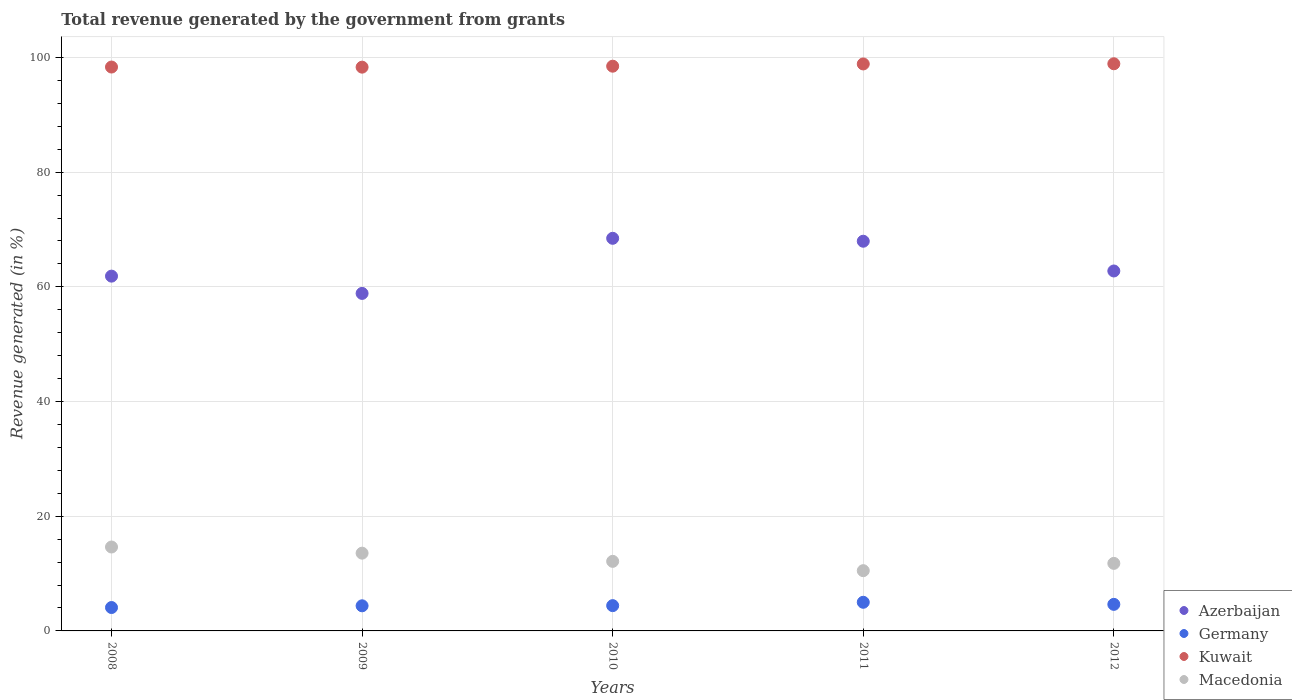How many different coloured dotlines are there?
Provide a succinct answer. 4. Is the number of dotlines equal to the number of legend labels?
Offer a very short reply. Yes. What is the total revenue generated in Macedonia in 2008?
Your response must be concise. 14.63. Across all years, what is the maximum total revenue generated in Macedonia?
Your answer should be very brief. 14.63. Across all years, what is the minimum total revenue generated in Kuwait?
Keep it short and to the point. 98.31. In which year was the total revenue generated in Macedonia maximum?
Provide a succinct answer. 2008. What is the total total revenue generated in Azerbaijan in the graph?
Offer a terse response. 319.89. What is the difference between the total revenue generated in Macedonia in 2009 and that in 2010?
Your answer should be very brief. 1.43. What is the difference between the total revenue generated in Azerbaijan in 2012 and the total revenue generated in Macedonia in 2009?
Provide a short and direct response. 49.2. What is the average total revenue generated in Azerbaijan per year?
Your response must be concise. 63.98. In the year 2012, what is the difference between the total revenue generated in Kuwait and total revenue generated in Germany?
Your answer should be very brief. 94.27. In how many years, is the total revenue generated in Kuwait greater than 64 %?
Make the answer very short. 5. What is the ratio of the total revenue generated in Kuwait in 2008 to that in 2010?
Offer a terse response. 1. Is the total revenue generated in Macedonia in 2010 less than that in 2012?
Provide a short and direct response. No. Is the difference between the total revenue generated in Kuwait in 2009 and 2011 greater than the difference between the total revenue generated in Germany in 2009 and 2011?
Your answer should be compact. Yes. What is the difference between the highest and the second highest total revenue generated in Azerbaijan?
Your answer should be very brief. 0.51. What is the difference between the highest and the lowest total revenue generated in Kuwait?
Provide a succinct answer. 0.59. In how many years, is the total revenue generated in Macedonia greater than the average total revenue generated in Macedonia taken over all years?
Offer a very short reply. 2. Is it the case that in every year, the sum of the total revenue generated in Azerbaijan and total revenue generated in Kuwait  is greater than the total revenue generated in Germany?
Your answer should be very brief. Yes. Is the total revenue generated in Macedonia strictly less than the total revenue generated in Azerbaijan over the years?
Your answer should be very brief. Yes. How many dotlines are there?
Give a very brief answer. 4. How many years are there in the graph?
Keep it short and to the point. 5. What is the difference between two consecutive major ticks on the Y-axis?
Make the answer very short. 20. Does the graph contain any zero values?
Ensure brevity in your answer.  No. Where does the legend appear in the graph?
Your answer should be compact. Bottom right. How many legend labels are there?
Provide a short and direct response. 4. What is the title of the graph?
Your answer should be compact. Total revenue generated by the government from grants. Does "Greenland" appear as one of the legend labels in the graph?
Offer a very short reply. No. What is the label or title of the Y-axis?
Offer a terse response. Revenue generated (in %). What is the Revenue generated (in %) in Azerbaijan in 2008?
Give a very brief answer. 61.87. What is the Revenue generated (in %) of Germany in 2008?
Give a very brief answer. 4.08. What is the Revenue generated (in %) in Kuwait in 2008?
Ensure brevity in your answer.  98.33. What is the Revenue generated (in %) in Macedonia in 2008?
Make the answer very short. 14.63. What is the Revenue generated (in %) of Azerbaijan in 2009?
Provide a succinct answer. 58.85. What is the Revenue generated (in %) of Germany in 2009?
Give a very brief answer. 4.38. What is the Revenue generated (in %) in Kuwait in 2009?
Keep it short and to the point. 98.31. What is the Revenue generated (in %) in Macedonia in 2009?
Ensure brevity in your answer.  13.56. What is the Revenue generated (in %) of Azerbaijan in 2010?
Ensure brevity in your answer.  68.46. What is the Revenue generated (in %) of Germany in 2010?
Offer a terse response. 4.41. What is the Revenue generated (in %) in Kuwait in 2010?
Your answer should be very brief. 98.47. What is the Revenue generated (in %) of Macedonia in 2010?
Your response must be concise. 12.13. What is the Revenue generated (in %) of Azerbaijan in 2011?
Your response must be concise. 67.95. What is the Revenue generated (in %) of Germany in 2011?
Your response must be concise. 4.99. What is the Revenue generated (in %) of Kuwait in 2011?
Offer a very short reply. 98.86. What is the Revenue generated (in %) in Macedonia in 2011?
Your answer should be compact. 10.51. What is the Revenue generated (in %) of Azerbaijan in 2012?
Keep it short and to the point. 62.76. What is the Revenue generated (in %) of Germany in 2012?
Keep it short and to the point. 4.63. What is the Revenue generated (in %) in Kuwait in 2012?
Offer a very short reply. 98.9. What is the Revenue generated (in %) of Macedonia in 2012?
Give a very brief answer. 11.78. Across all years, what is the maximum Revenue generated (in %) in Azerbaijan?
Your answer should be very brief. 68.46. Across all years, what is the maximum Revenue generated (in %) of Germany?
Provide a short and direct response. 4.99. Across all years, what is the maximum Revenue generated (in %) of Kuwait?
Ensure brevity in your answer.  98.9. Across all years, what is the maximum Revenue generated (in %) of Macedonia?
Make the answer very short. 14.63. Across all years, what is the minimum Revenue generated (in %) of Azerbaijan?
Provide a succinct answer. 58.85. Across all years, what is the minimum Revenue generated (in %) in Germany?
Keep it short and to the point. 4.08. Across all years, what is the minimum Revenue generated (in %) in Kuwait?
Offer a very short reply. 98.31. Across all years, what is the minimum Revenue generated (in %) of Macedonia?
Offer a terse response. 10.51. What is the total Revenue generated (in %) in Azerbaijan in the graph?
Your answer should be compact. 319.89. What is the total Revenue generated (in %) in Germany in the graph?
Offer a very short reply. 22.49. What is the total Revenue generated (in %) in Kuwait in the graph?
Your response must be concise. 492.87. What is the total Revenue generated (in %) of Macedonia in the graph?
Provide a succinct answer. 62.61. What is the difference between the Revenue generated (in %) of Azerbaijan in 2008 and that in 2009?
Offer a very short reply. 3.01. What is the difference between the Revenue generated (in %) in Germany in 2008 and that in 2009?
Offer a very short reply. -0.3. What is the difference between the Revenue generated (in %) of Kuwait in 2008 and that in 2009?
Your response must be concise. 0.02. What is the difference between the Revenue generated (in %) in Macedonia in 2008 and that in 2009?
Make the answer very short. 1.07. What is the difference between the Revenue generated (in %) of Azerbaijan in 2008 and that in 2010?
Your answer should be compact. -6.6. What is the difference between the Revenue generated (in %) of Germany in 2008 and that in 2010?
Your response must be concise. -0.33. What is the difference between the Revenue generated (in %) of Kuwait in 2008 and that in 2010?
Provide a short and direct response. -0.15. What is the difference between the Revenue generated (in %) of Macedonia in 2008 and that in 2010?
Make the answer very short. 2.5. What is the difference between the Revenue generated (in %) of Azerbaijan in 2008 and that in 2011?
Ensure brevity in your answer.  -6.09. What is the difference between the Revenue generated (in %) of Germany in 2008 and that in 2011?
Offer a very short reply. -0.91. What is the difference between the Revenue generated (in %) in Kuwait in 2008 and that in 2011?
Ensure brevity in your answer.  -0.54. What is the difference between the Revenue generated (in %) of Macedonia in 2008 and that in 2011?
Provide a succinct answer. 4.12. What is the difference between the Revenue generated (in %) of Azerbaijan in 2008 and that in 2012?
Keep it short and to the point. -0.9. What is the difference between the Revenue generated (in %) in Germany in 2008 and that in 2012?
Offer a very short reply. -0.55. What is the difference between the Revenue generated (in %) in Kuwait in 2008 and that in 2012?
Your answer should be compact. -0.57. What is the difference between the Revenue generated (in %) in Macedonia in 2008 and that in 2012?
Offer a very short reply. 2.85. What is the difference between the Revenue generated (in %) of Azerbaijan in 2009 and that in 2010?
Provide a succinct answer. -9.61. What is the difference between the Revenue generated (in %) of Germany in 2009 and that in 2010?
Your answer should be very brief. -0.03. What is the difference between the Revenue generated (in %) in Kuwait in 2009 and that in 2010?
Provide a short and direct response. -0.17. What is the difference between the Revenue generated (in %) in Macedonia in 2009 and that in 2010?
Your answer should be compact. 1.43. What is the difference between the Revenue generated (in %) in Azerbaijan in 2009 and that in 2011?
Make the answer very short. -9.1. What is the difference between the Revenue generated (in %) in Germany in 2009 and that in 2011?
Give a very brief answer. -0.61. What is the difference between the Revenue generated (in %) in Kuwait in 2009 and that in 2011?
Keep it short and to the point. -0.56. What is the difference between the Revenue generated (in %) in Macedonia in 2009 and that in 2011?
Your answer should be very brief. 3.05. What is the difference between the Revenue generated (in %) of Azerbaijan in 2009 and that in 2012?
Ensure brevity in your answer.  -3.91. What is the difference between the Revenue generated (in %) in Germany in 2009 and that in 2012?
Offer a very short reply. -0.25. What is the difference between the Revenue generated (in %) in Kuwait in 2009 and that in 2012?
Offer a terse response. -0.59. What is the difference between the Revenue generated (in %) of Macedonia in 2009 and that in 2012?
Your answer should be very brief. 1.78. What is the difference between the Revenue generated (in %) of Azerbaijan in 2010 and that in 2011?
Offer a terse response. 0.51. What is the difference between the Revenue generated (in %) of Germany in 2010 and that in 2011?
Give a very brief answer. -0.59. What is the difference between the Revenue generated (in %) of Kuwait in 2010 and that in 2011?
Offer a very short reply. -0.39. What is the difference between the Revenue generated (in %) of Macedonia in 2010 and that in 2011?
Offer a terse response. 1.63. What is the difference between the Revenue generated (in %) of Azerbaijan in 2010 and that in 2012?
Give a very brief answer. 5.7. What is the difference between the Revenue generated (in %) in Germany in 2010 and that in 2012?
Keep it short and to the point. -0.22. What is the difference between the Revenue generated (in %) of Kuwait in 2010 and that in 2012?
Ensure brevity in your answer.  -0.42. What is the difference between the Revenue generated (in %) of Macedonia in 2010 and that in 2012?
Provide a short and direct response. 0.35. What is the difference between the Revenue generated (in %) in Azerbaijan in 2011 and that in 2012?
Your answer should be very brief. 5.19. What is the difference between the Revenue generated (in %) of Germany in 2011 and that in 2012?
Ensure brevity in your answer.  0.36. What is the difference between the Revenue generated (in %) in Kuwait in 2011 and that in 2012?
Your answer should be very brief. -0.03. What is the difference between the Revenue generated (in %) in Macedonia in 2011 and that in 2012?
Keep it short and to the point. -1.27. What is the difference between the Revenue generated (in %) in Azerbaijan in 2008 and the Revenue generated (in %) in Germany in 2009?
Your response must be concise. 57.49. What is the difference between the Revenue generated (in %) in Azerbaijan in 2008 and the Revenue generated (in %) in Kuwait in 2009?
Offer a very short reply. -36.44. What is the difference between the Revenue generated (in %) of Azerbaijan in 2008 and the Revenue generated (in %) of Macedonia in 2009?
Give a very brief answer. 48.3. What is the difference between the Revenue generated (in %) of Germany in 2008 and the Revenue generated (in %) of Kuwait in 2009?
Your response must be concise. -94.23. What is the difference between the Revenue generated (in %) in Germany in 2008 and the Revenue generated (in %) in Macedonia in 2009?
Ensure brevity in your answer.  -9.48. What is the difference between the Revenue generated (in %) in Kuwait in 2008 and the Revenue generated (in %) in Macedonia in 2009?
Provide a short and direct response. 84.77. What is the difference between the Revenue generated (in %) in Azerbaijan in 2008 and the Revenue generated (in %) in Germany in 2010?
Give a very brief answer. 57.46. What is the difference between the Revenue generated (in %) of Azerbaijan in 2008 and the Revenue generated (in %) of Kuwait in 2010?
Offer a very short reply. -36.61. What is the difference between the Revenue generated (in %) of Azerbaijan in 2008 and the Revenue generated (in %) of Macedonia in 2010?
Ensure brevity in your answer.  49.73. What is the difference between the Revenue generated (in %) of Germany in 2008 and the Revenue generated (in %) of Kuwait in 2010?
Provide a short and direct response. -94.4. What is the difference between the Revenue generated (in %) of Germany in 2008 and the Revenue generated (in %) of Macedonia in 2010?
Offer a terse response. -8.05. What is the difference between the Revenue generated (in %) of Kuwait in 2008 and the Revenue generated (in %) of Macedonia in 2010?
Provide a succinct answer. 86.19. What is the difference between the Revenue generated (in %) of Azerbaijan in 2008 and the Revenue generated (in %) of Germany in 2011?
Ensure brevity in your answer.  56.87. What is the difference between the Revenue generated (in %) in Azerbaijan in 2008 and the Revenue generated (in %) in Kuwait in 2011?
Provide a short and direct response. -37. What is the difference between the Revenue generated (in %) of Azerbaijan in 2008 and the Revenue generated (in %) of Macedonia in 2011?
Keep it short and to the point. 51.36. What is the difference between the Revenue generated (in %) in Germany in 2008 and the Revenue generated (in %) in Kuwait in 2011?
Keep it short and to the point. -94.79. What is the difference between the Revenue generated (in %) in Germany in 2008 and the Revenue generated (in %) in Macedonia in 2011?
Your answer should be very brief. -6.43. What is the difference between the Revenue generated (in %) of Kuwait in 2008 and the Revenue generated (in %) of Macedonia in 2011?
Ensure brevity in your answer.  87.82. What is the difference between the Revenue generated (in %) in Azerbaijan in 2008 and the Revenue generated (in %) in Germany in 2012?
Your answer should be very brief. 57.23. What is the difference between the Revenue generated (in %) of Azerbaijan in 2008 and the Revenue generated (in %) of Kuwait in 2012?
Your response must be concise. -37.03. What is the difference between the Revenue generated (in %) in Azerbaijan in 2008 and the Revenue generated (in %) in Macedonia in 2012?
Your answer should be very brief. 50.09. What is the difference between the Revenue generated (in %) of Germany in 2008 and the Revenue generated (in %) of Kuwait in 2012?
Give a very brief answer. -94.82. What is the difference between the Revenue generated (in %) of Germany in 2008 and the Revenue generated (in %) of Macedonia in 2012?
Your answer should be very brief. -7.7. What is the difference between the Revenue generated (in %) of Kuwait in 2008 and the Revenue generated (in %) of Macedonia in 2012?
Provide a succinct answer. 86.55. What is the difference between the Revenue generated (in %) in Azerbaijan in 2009 and the Revenue generated (in %) in Germany in 2010?
Your response must be concise. 54.44. What is the difference between the Revenue generated (in %) of Azerbaijan in 2009 and the Revenue generated (in %) of Kuwait in 2010?
Your response must be concise. -39.62. What is the difference between the Revenue generated (in %) in Azerbaijan in 2009 and the Revenue generated (in %) in Macedonia in 2010?
Offer a very short reply. 46.72. What is the difference between the Revenue generated (in %) of Germany in 2009 and the Revenue generated (in %) of Kuwait in 2010?
Keep it short and to the point. -94.1. What is the difference between the Revenue generated (in %) in Germany in 2009 and the Revenue generated (in %) in Macedonia in 2010?
Your answer should be very brief. -7.75. What is the difference between the Revenue generated (in %) of Kuwait in 2009 and the Revenue generated (in %) of Macedonia in 2010?
Provide a succinct answer. 86.17. What is the difference between the Revenue generated (in %) of Azerbaijan in 2009 and the Revenue generated (in %) of Germany in 2011?
Provide a short and direct response. 53.86. What is the difference between the Revenue generated (in %) of Azerbaijan in 2009 and the Revenue generated (in %) of Kuwait in 2011?
Your answer should be very brief. -40.01. What is the difference between the Revenue generated (in %) in Azerbaijan in 2009 and the Revenue generated (in %) in Macedonia in 2011?
Your answer should be compact. 48.35. What is the difference between the Revenue generated (in %) in Germany in 2009 and the Revenue generated (in %) in Kuwait in 2011?
Give a very brief answer. -94.49. What is the difference between the Revenue generated (in %) of Germany in 2009 and the Revenue generated (in %) of Macedonia in 2011?
Provide a short and direct response. -6.13. What is the difference between the Revenue generated (in %) in Kuwait in 2009 and the Revenue generated (in %) in Macedonia in 2011?
Give a very brief answer. 87.8. What is the difference between the Revenue generated (in %) in Azerbaijan in 2009 and the Revenue generated (in %) in Germany in 2012?
Your answer should be compact. 54.22. What is the difference between the Revenue generated (in %) in Azerbaijan in 2009 and the Revenue generated (in %) in Kuwait in 2012?
Provide a succinct answer. -40.05. What is the difference between the Revenue generated (in %) in Azerbaijan in 2009 and the Revenue generated (in %) in Macedonia in 2012?
Provide a succinct answer. 47.07. What is the difference between the Revenue generated (in %) of Germany in 2009 and the Revenue generated (in %) of Kuwait in 2012?
Give a very brief answer. -94.52. What is the difference between the Revenue generated (in %) of Germany in 2009 and the Revenue generated (in %) of Macedonia in 2012?
Provide a succinct answer. -7.4. What is the difference between the Revenue generated (in %) in Kuwait in 2009 and the Revenue generated (in %) in Macedonia in 2012?
Offer a very short reply. 86.53. What is the difference between the Revenue generated (in %) in Azerbaijan in 2010 and the Revenue generated (in %) in Germany in 2011?
Ensure brevity in your answer.  63.47. What is the difference between the Revenue generated (in %) of Azerbaijan in 2010 and the Revenue generated (in %) of Kuwait in 2011?
Provide a succinct answer. -30.4. What is the difference between the Revenue generated (in %) in Azerbaijan in 2010 and the Revenue generated (in %) in Macedonia in 2011?
Provide a short and direct response. 57.96. What is the difference between the Revenue generated (in %) in Germany in 2010 and the Revenue generated (in %) in Kuwait in 2011?
Provide a short and direct response. -94.46. What is the difference between the Revenue generated (in %) in Germany in 2010 and the Revenue generated (in %) in Macedonia in 2011?
Give a very brief answer. -6.1. What is the difference between the Revenue generated (in %) in Kuwait in 2010 and the Revenue generated (in %) in Macedonia in 2011?
Provide a succinct answer. 87.97. What is the difference between the Revenue generated (in %) in Azerbaijan in 2010 and the Revenue generated (in %) in Germany in 2012?
Offer a very short reply. 63.83. What is the difference between the Revenue generated (in %) in Azerbaijan in 2010 and the Revenue generated (in %) in Kuwait in 2012?
Ensure brevity in your answer.  -30.44. What is the difference between the Revenue generated (in %) of Azerbaijan in 2010 and the Revenue generated (in %) of Macedonia in 2012?
Provide a succinct answer. 56.68. What is the difference between the Revenue generated (in %) of Germany in 2010 and the Revenue generated (in %) of Kuwait in 2012?
Keep it short and to the point. -94.49. What is the difference between the Revenue generated (in %) of Germany in 2010 and the Revenue generated (in %) of Macedonia in 2012?
Provide a succinct answer. -7.37. What is the difference between the Revenue generated (in %) in Kuwait in 2010 and the Revenue generated (in %) in Macedonia in 2012?
Offer a terse response. 86.7. What is the difference between the Revenue generated (in %) in Azerbaijan in 2011 and the Revenue generated (in %) in Germany in 2012?
Provide a short and direct response. 63.32. What is the difference between the Revenue generated (in %) of Azerbaijan in 2011 and the Revenue generated (in %) of Kuwait in 2012?
Give a very brief answer. -30.95. What is the difference between the Revenue generated (in %) in Azerbaijan in 2011 and the Revenue generated (in %) in Macedonia in 2012?
Provide a succinct answer. 56.17. What is the difference between the Revenue generated (in %) of Germany in 2011 and the Revenue generated (in %) of Kuwait in 2012?
Offer a very short reply. -93.9. What is the difference between the Revenue generated (in %) in Germany in 2011 and the Revenue generated (in %) in Macedonia in 2012?
Offer a very short reply. -6.78. What is the difference between the Revenue generated (in %) of Kuwait in 2011 and the Revenue generated (in %) of Macedonia in 2012?
Ensure brevity in your answer.  87.09. What is the average Revenue generated (in %) in Azerbaijan per year?
Your answer should be very brief. 63.98. What is the average Revenue generated (in %) in Germany per year?
Your answer should be very brief. 4.5. What is the average Revenue generated (in %) of Kuwait per year?
Offer a very short reply. 98.57. What is the average Revenue generated (in %) in Macedonia per year?
Offer a very short reply. 12.52. In the year 2008, what is the difference between the Revenue generated (in %) in Azerbaijan and Revenue generated (in %) in Germany?
Ensure brevity in your answer.  57.79. In the year 2008, what is the difference between the Revenue generated (in %) in Azerbaijan and Revenue generated (in %) in Kuwait?
Offer a very short reply. -36.46. In the year 2008, what is the difference between the Revenue generated (in %) of Azerbaijan and Revenue generated (in %) of Macedonia?
Make the answer very short. 47.23. In the year 2008, what is the difference between the Revenue generated (in %) of Germany and Revenue generated (in %) of Kuwait?
Give a very brief answer. -94.25. In the year 2008, what is the difference between the Revenue generated (in %) of Germany and Revenue generated (in %) of Macedonia?
Give a very brief answer. -10.55. In the year 2008, what is the difference between the Revenue generated (in %) of Kuwait and Revenue generated (in %) of Macedonia?
Provide a short and direct response. 83.69. In the year 2009, what is the difference between the Revenue generated (in %) of Azerbaijan and Revenue generated (in %) of Germany?
Provide a short and direct response. 54.47. In the year 2009, what is the difference between the Revenue generated (in %) of Azerbaijan and Revenue generated (in %) of Kuwait?
Provide a succinct answer. -39.45. In the year 2009, what is the difference between the Revenue generated (in %) of Azerbaijan and Revenue generated (in %) of Macedonia?
Make the answer very short. 45.29. In the year 2009, what is the difference between the Revenue generated (in %) of Germany and Revenue generated (in %) of Kuwait?
Give a very brief answer. -93.93. In the year 2009, what is the difference between the Revenue generated (in %) in Germany and Revenue generated (in %) in Macedonia?
Your answer should be very brief. -9.18. In the year 2009, what is the difference between the Revenue generated (in %) in Kuwait and Revenue generated (in %) in Macedonia?
Your answer should be compact. 84.75. In the year 2010, what is the difference between the Revenue generated (in %) of Azerbaijan and Revenue generated (in %) of Germany?
Provide a succinct answer. 64.05. In the year 2010, what is the difference between the Revenue generated (in %) of Azerbaijan and Revenue generated (in %) of Kuwait?
Give a very brief answer. -30.01. In the year 2010, what is the difference between the Revenue generated (in %) in Azerbaijan and Revenue generated (in %) in Macedonia?
Offer a terse response. 56.33. In the year 2010, what is the difference between the Revenue generated (in %) of Germany and Revenue generated (in %) of Kuwait?
Make the answer very short. -94.07. In the year 2010, what is the difference between the Revenue generated (in %) of Germany and Revenue generated (in %) of Macedonia?
Your answer should be very brief. -7.72. In the year 2010, what is the difference between the Revenue generated (in %) in Kuwait and Revenue generated (in %) in Macedonia?
Ensure brevity in your answer.  86.34. In the year 2011, what is the difference between the Revenue generated (in %) of Azerbaijan and Revenue generated (in %) of Germany?
Your answer should be very brief. 62.96. In the year 2011, what is the difference between the Revenue generated (in %) in Azerbaijan and Revenue generated (in %) in Kuwait?
Your answer should be very brief. -30.91. In the year 2011, what is the difference between the Revenue generated (in %) in Azerbaijan and Revenue generated (in %) in Macedonia?
Provide a succinct answer. 57.45. In the year 2011, what is the difference between the Revenue generated (in %) in Germany and Revenue generated (in %) in Kuwait?
Make the answer very short. -93.87. In the year 2011, what is the difference between the Revenue generated (in %) of Germany and Revenue generated (in %) of Macedonia?
Offer a very short reply. -5.51. In the year 2011, what is the difference between the Revenue generated (in %) of Kuwait and Revenue generated (in %) of Macedonia?
Provide a short and direct response. 88.36. In the year 2012, what is the difference between the Revenue generated (in %) in Azerbaijan and Revenue generated (in %) in Germany?
Keep it short and to the point. 58.13. In the year 2012, what is the difference between the Revenue generated (in %) of Azerbaijan and Revenue generated (in %) of Kuwait?
Your response must be concise. -36.13. In the year 2012, what is the difference between the Revenue generated (in %) of Azerbaijan and Revenue generated (in %) of Macedonia?
Keep it short and to the point. 50.99. In the year 2012, what is the difference between the Revenue generated (in %) of Germany and Revenue generated (in %) of Kuwait?
Your response must be concise. -94.27. In the year 2012, what is the difference between the Revenue generated (in %) in Germany and Revenue generated (in %) in Macedonia?
Your answer should be compact. -7.15. In the year 2012, what is the difference between the Revenue generated (in %) in Kuwait and Revenue generated (in %) in Macedonia?
Your answer should be very brief. 87.12. What is the ratio of the Revenue generated (in %) in Azerbaijan in 2008 to that in 2009?
Keep it short and to the point. 1.05. What is the ratio of the Revenue generated (in %) of Germany in 2008 to that in 2009?
Make the answer very short. 0.93. What is the ratio of the Revenue generated (in %) in Kuwait in 2008 to that in 2009?
Your answer should be very brief. 1. What is the ratio of the Revenue generated (in %) in Macedonia in 2008 to that in 2009?
Provide a short and direct response. 1.08. What is the ratio of the Revenue generated (in %) in Azerbaijan in 2008 to that in 2010?
Ensure brevity in your answer.  0.9. What is the ratio of the Revenue generated (in %) in Germany in 2008 to that in 2010?
Your response must be concise. 0.93. What is the ratio of the Revenue generated (in %) in Macedonia in 2008 to that in 2010?
Your answer should be very brief. 1.21. What is the ratio of the Revenue generated (in %) of Azerbaijan in 2008 to that in 2011?
Your answer should be compact. 0.91. What is the ratio of the Revenue generated (in %) of Germany in 2008 to that in 2011?
Make the answer very short. 0.82. What is the ratio of the Revenue generated (in %) of Kuwait in 2008 to that in 2011?
Your response must be concise. 0.99. What is the ratio of the Revenue generated (in %) in Macedonia in 2008 to that in 2011?
Make the answer very short. 1.39. What is the ratio of the Revenue generated (in %) of Azerbaijan in 2008 to that in 2012?
Your answer should be very brief. 0.99. What is the ratio of the Revenue generated (in %) of Germany in 2008 to that in 2012?
Your answer should be compact. 0.88. What is the ratio of the Revenue generated (in %) in Kuwait in 2008 to that in 2012?
Make the answer very short. 0.99. What is the ratio of the Revenue generated (in %) of Macedonia in 2008 to that in 2012?
Provide a succinct answer. 1.24. What is the ratio of the Revenue generated (in %) in Azerbaijan in 2009 to that in 2010?
Your answer should be very brief. 0.86. What is the ratio of the Revenue generated (in %) in Kuwait in 2009 to that in 2010?
Your answer should be very brief. 1. What is the ratio of the Revenue generated (in %) of Macedonia in 2009 to that in 2010?
Ensure brevity in your answer.  1.12. What is the ratio of the Revenue generated (in %) in Azerbaijan in 2009 to that in 2011?
Make the answer very short. 0.87. What is the ratio of the Revenue generated (in %) of Germany in 2009 to that in 2011?
Keep it short and to the point. 0.88. What is the ratio of the Revenue generated (in %) in Kuwait in 2009 to that in 2011?
Your answer should be compact. 0.99. What is the ratio of the Revenue generated (in %) in Macedonia in 2009 to that in 2011?
Offer a very short reply. 1.29. What is the ratio of the Revenue generated (in %) in Azerbaijan in 2009 to that in 2012?
Offer a very short reply. 0.94. What is the ratio of the Revenue generated (in %) in Germany in 2009 to that in 2012?
Provide a short and direct response. 0.95. What is the ratio of the Revenue generated (in %) of Kuwait in 2009 to that in 2012?
Make the answer very short. 0.99. What is the ratio of the Revenue generated (in %) in Macedonia in 2009 to that in 2012?
Offer a very short reply. 1.15. What is the ratio of the Revenue generated (in %) of Azerbaijan in 2010 to that in 2011?
Your response must be concise. 1.01. What is the ratio of the Revenue generated (in %) in Germany in 2010 to that in 2011?
Make the answer very short. 0.88. What is the ratio of the Revenue generated (in %) in Kuwait in 2010 to that in 2011?
Offer a terse response. 1. What is the ratio of the Revenue generated (in %) in Macedonia in 2010 to that in 2011?
Keep it short and to the point. 1.15. What is the ratio of the Revenue generated (in %) in Azerbaijan in 2010 to that in 2012?
Make the answer very short. 1.09. What is the ratio of the Revenue generated (in %) in Germany in 2010 to that in 2012?
Provide a short and direct response. 0.95. What is the ratio of the Revenue generated (in %) in Azerbaijan in 2011 to that in 2012?
Provide a short and direct response. 1.08. What is the ratio of the Revenue generated (in %) in Germany in 2011 to that in 2012?
Make the answer very short. 1.08. What is the ratio of the Revenue generated (in %) in Macedonia in 2011 to that in 2012?
Provide a succinct answer. 0.89. What is the difference between the highest and the second highest Revenue generated (in %) of Azerbaijan?
Provide a succinct answer. 0.51. What is the difference between the highest and the second highest Revenue generated (in %) of Germany?
Your answer should be compact. 0.36. What is the difference between the highest and the second highest Revenue generated (in %) of Kuwait?
Provide a short and direct response. 0.03. What is the difference between the highest and the second highest Revenue generated (in %) of Macedonia?
Make the answer very short. 1.07. What is the difference between the highest and the lowest Revenue generated (in %) of Azerbaijan?
Your response must be concise. 9.61. What is the difference between the highest and the lowest Revenue generated (in %) of Germany?
Ensure brevity in your answer.  0.91. What is the difference between the highest and the lowest Revenue generated (in %) of Kuwait?
Your response must be concise. 0.59. What is the difference between the highest and the lowest Revenue generated (in %) in Macedonia?
Provide a succinct answer. 4.12. 